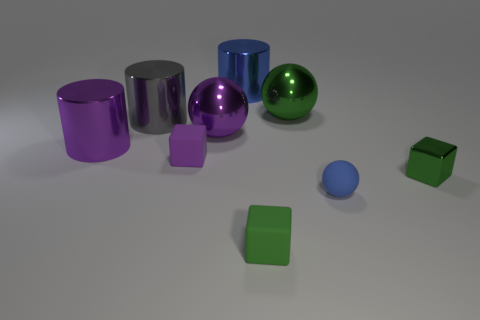What size is the green ball that is made of the same material as the gray object?
Provide a short and direct response. Large. There is a green shiny object that is in front of the purple thing that is to the left of the tiny block left of the big blue metal object; what shape is it?
Provide a succinct answer. Cube. Is the number of purple balls to the left of the purple metal cylinder the same as the number of metallic cylinders?
Provide a short and direct response. No. There is a metal cylinder that is the same color as the matte ball; what is its size?
Offer a terse response. Large. Do the large gray shiny object and the large green thing have the same shape?
Provide a succinct answer. No. How many things are large spheres left of the green metal sphere or small red shiny cylinders?
Offer a terse response. 1. Are there the same number of large gray shiny cylinders that are in front of the blue cylinder and blue objects that are in front of the small green shiny object?
Your answer should be very brief. Yes. What number of other objects are the same shape as the big green metallic thing?
Your answer should be compact. 2. Is the size of the shiny cylinder that is in front of the large purple shiny sphere the same as the blue sphere in front of the tiny purple rubber cube?
Your answer should be very brief. No. How many cubes are tiny yellow shiny objects or tiny green things?
Keep it short and to the point. 2. 